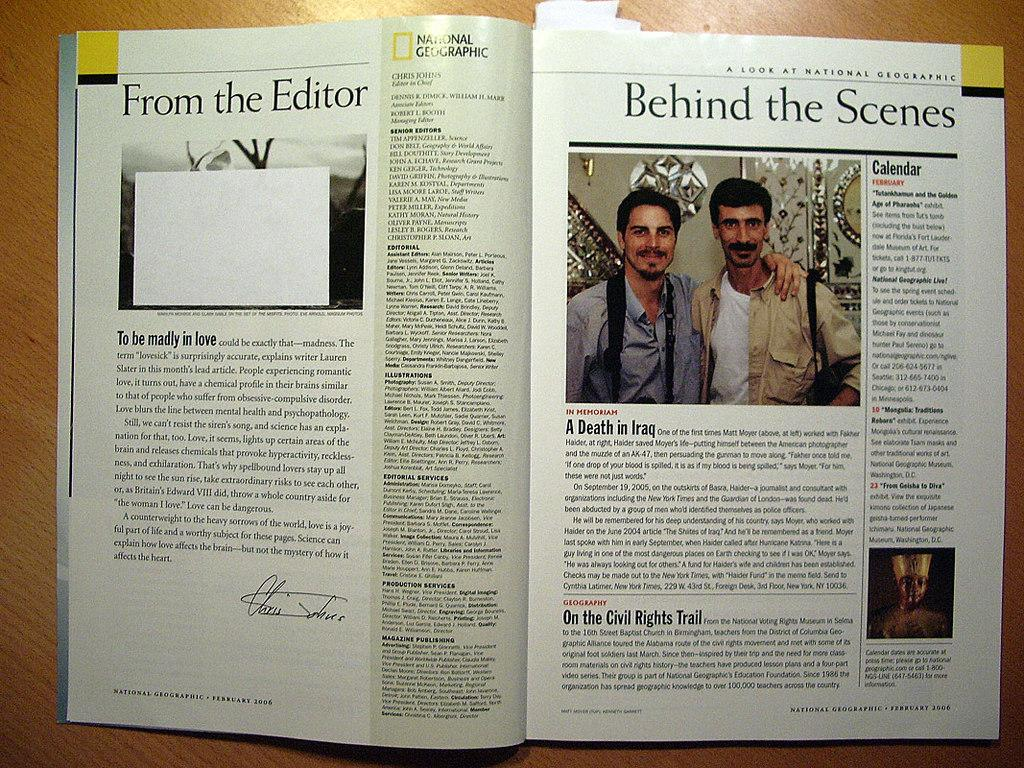Provide a one-sentence caption for the provided image. The inside of a National Geographic magazine that shows a commentary on Iraq and the Civil Rights movement. 